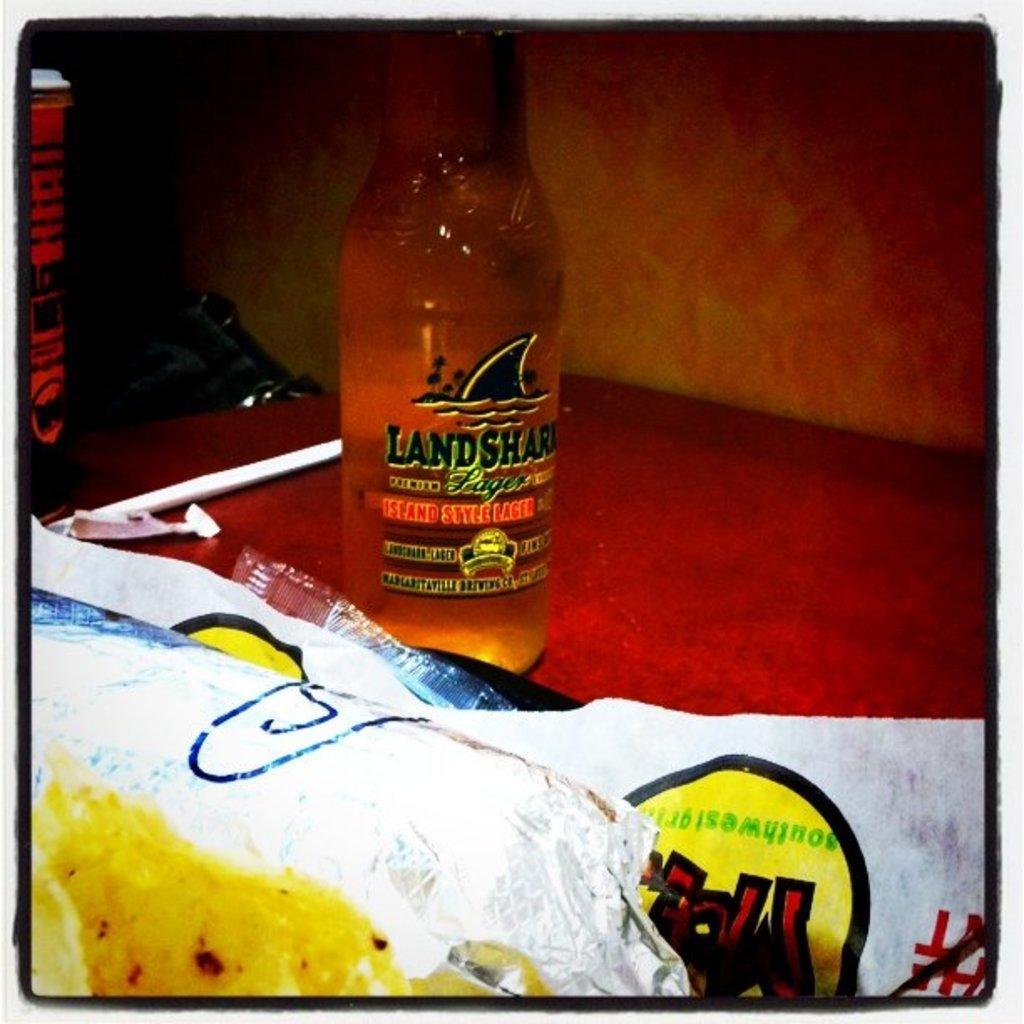Could you give a brief overview of what you see in this image? In this image i can see a bottle which is on the table. 